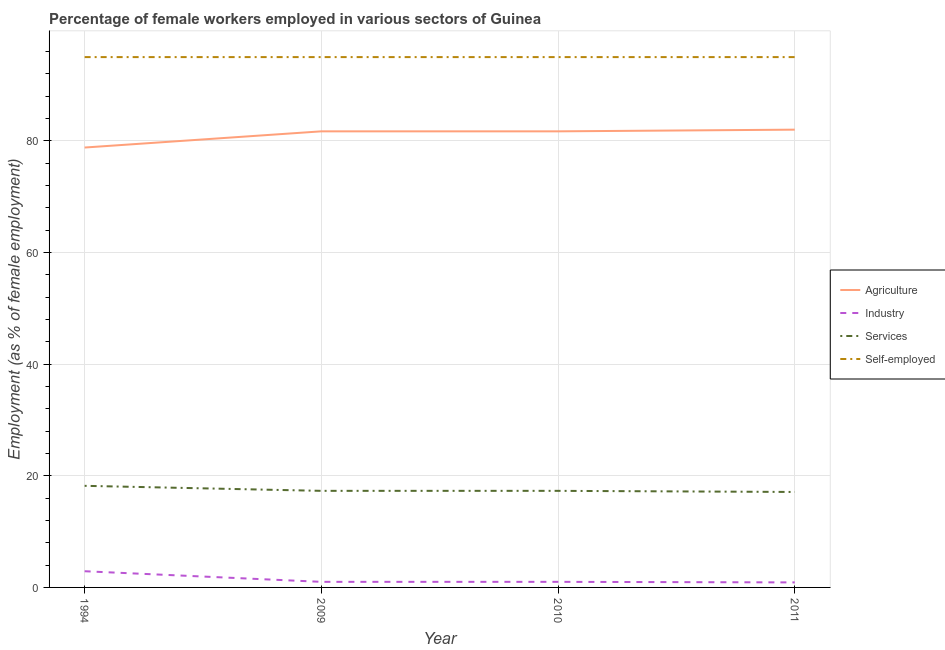How many different coloured lines are there?
Give a very brief answer. 4. What is the percentage of female workers in industry in 1994?
Give a very brief answer. 2.9. Across all years, what is the minimum percentage of self employed female workers?
Keep it short and to the point. 95. In which year was the percentage of self employed female workers maximum?
Offer a terse response. 1994. What is the total percentage of self employed female workers in the graph?
Offer a very short reply. 380. What is the difference between the percentage of female workers in services in 1994 and the percentage of female workers in agriculture in 2010?
Make the answer very short. -63.5. What is the average percentage of female workers in industry per year?
Provide a short and direct response. 1.45. In the year 1994, what is the difference between the percentage of self employed female workers and percentage of female workers in agriculture?
Offer a very short reply. 16.2. In how many years, is the percentage of female workers in services greater than 24 %?
Offer a very short reply. 0. What is the ratio of the percentage of female workers in agriculture in 1994 to that in 2010?
Keep it short and to the point. 0.96. Is the percentage of female workers in services in 1994 less than that in 2010?
Give a very brief answer. No. Is the difference between the percentage of female workers in services in 2009 and 2011 greater than the difference between the percentage of female workers in agriculture in 2009 and 2011?
Provide a short and direct response. Yes. What is the difference between the highest and the second highest percentage of female workers in agriculture?
Keep it short and to the point. 0.3. What is the difference between the highest and the lowest percentage of female workers in services?
Your answer should be compact. 1.1. Is the sum of the percentage of female workers in services in 2009 and 2010 greater than the maximum percentage of female workers in industry across all years?
Your response must be concise. Yes. Is it the case that in every year, the sum of the percentage of female workers in industry and percentage of female workers in agriculture is greater than the sum of percentage of female workers in services and percentage of self employed female workers?
Give a very brief answer. No. Is it the case that in every year, the sum of the percentage of female workers in agriculture and percentage of female workers in industry is greater than the percentage of female workers in services?
Give a very brief answer. Yes. Is the percentage of female workers in agriculture strictly greater than the percentage of female workers in industry over the years?
Your answer should be very brief. Yes. Are the values on the major ticks of Y-axis written in scientific E-notation?
Keep it short and to the point. No. Does the graph contain any zero values?
Ensure brevity in your answer.  No. Does the graph contain grids?
Provide a succinct answer. Yes. Where does the legend appear in the graph?
Provide a short and direct response. Center right. How many legend labels are there?
Offer a very short reply. 4. How are the legend labels stacked?
Make the answer very short. Vertical. What is the title of the graph?
Provide a succinct answer. Percentage of female workers employed in various sectors of Guinea. What is the label or title of the Y-axis?
Offer a terse response. Employment (as % of female employment). What is the Employment (as % of female employment) in Agriculture in 1994?
Keep it short and to the point. 78.8. What is the Employment (as % of female employment) of Industry in 1994?
Offer a terse response. 2.9. What is the Employment (as % of female employment) of Services in 1994?
Offer a very short reply. 18.2. What is the Employment (as % of female employment) of Self-employed in 1994?
Your answer should be compact. 95. What is the Employment (as % of female employment) of Agriculture in 2009?
Provide a short and direct response. 81.7. What is the Employment (as % of female employment) in Services in 2009?
Your answer should be very brief. 17.3. What is the Employment (as % of female employment) in Self-employed in 2009?
Make the answer very short. 95. What is the Employment (as % of female employment) in Agriculture in 2010?
Your answer should be very brief. 81.7. What is the Employment (as % of female employment) in Industry in 2010?
Give a very brief answer. 1. What is the Employment (as % of female employment) of Services in 2010?
Provide a succinct answer. 17.3. What is the Employment (as % of female employment) of Self-employed in 2010?
Your response must be concise. 95. What is the Employment (as % of female employment) in Agriculture in 2011?
Make the answer very short. 82. What is the Employment (as % of female employment) of Industry in 2011?
Your answer should be very brief. 0.9. What is the Employment (as % of female employment) of Services in 2011?
Make the answer very short. 17.1. What is the Employment (as % of female employment) in Self-employed in 2011?
Your answer should be very brief. 95. Across all years, what is the maximum Employment (as % of female employment) in Industry?
Your answer should be very brief. 2.9. Across all years, what is the maximum Employment (as % of female employment) of Services?
Make the answer very short. 18.2. Across all years, what is the minimum Employment (as % of female employment) in Agriculture?
Ensure brevity in your answer.  78.8. Across all years, what is the minimum Employment (as % of female employment) in Industry?
Give a very brief answer. 0.9. Across all years, what is the minimum Employment (as % of female employment) of Services?
Your response must be concise. 17.1. Across all years, what is the minimum Employment (as % of female employment) of Self-employed?
Provide a short and direct response. 95. What is the total Employment (as % of female employment) of Agriculture in the graph?
Ensure brevity in your answer.  324.2. What is the total Employment (as % of female employment) in Services in the graph?
Ensure brevity in your answer.  69.9. What is the total Employment (as % of female employment) in Self-employed in the graph?
Your answer should be very brief. 380. What is the difference between the Employment (as % of female employment) in Agriculture in 1994 and that in 2009?
Offer a very short reply. -2.9. What is the difference between the Employment (as % of female employment) in Industry in 1994 and that in 2009?
Keep it short and to the point. 1.9. What is the difference between the Employment (as % of female employment) in Industry in 1994 and that in 2010?
Your response must be concise. 1.9. What is the difference between the Employment (as % of female employment) in Services in 1994 and that in 2010?
Ensure brevity in your answer.  0.9. What is the difference between the Employment (as % of female employment) of Self-employed in 1994 and that in 2010?
Your answer should be compact. 0. What is the difference between the Employment (as % of female employment) in Industry in 1994 and that in 2011?
Make the answer very short. 2. What is the difference between the Employment (as % of female employment) of Services in 1994 and that in 2011?
Offer a very short reply. 1.1. What is the difference between the Employment (as % of female employment) of Self-employed in 1994 and that in 2011?
Your response must be concise. 0. What is the difference between the Employment (as % of female employment) in Services in 2009 and that in 2010?
Keep it short and to the point. 0. What is the difference between the Employment (as % of female employment) of Agriculture in 2009 and that in 2011?
Provide a short and direct response. -0.3. What is the difference between the Employment (as % of female employment) of Industry in 2009 and that in 2011?
Offer a very short reply. 0.1. What is the difference between the Employment (as % of female employment) of Self-employed in 2009 and that in 2011?
Offer a very short reply. 0. What is the difference between the Employment (as % of female employment) in Services in 2010 and that in 2011?
Ensure brevity in your answer.  0.2. What is the difference between the Employment (as % of female employment) in Agriculture in 1994 and the Employment (as % of female employment) in Industry in 2009?
Your answer should be very brief. 77.8. What is the difference between the Employment (as % of female employment) in Agriculture in 1994 and the Employment (as % of female employment) in Services in 2009?
Offer a very short reply. 61.5. What is the difference between the Employment (as % of female employment) in Agriculture in 1994 and the Employment (as % of female employment) in Self-employed in 2009?
Your answer should be compact. -16.2. What is the difference between the Employment (as % of female employment) of Industry in 1994 and the Employment (as % of female employment) of Services in 2009?
Your answer should be compact. -14.4. What is the difference between the Employment (as % of female employment) in Industry in 1994 and the Employment (as % of female employment) in Self-employed in 2009?
Give a very brief answer. -92.1. What is the difference between the Employment (as % of female employment) of Services in 1994 and the Employment (as % of female employment) of Self-employed in 2009?
Offer a very short reply. -76.8. What is the difference between the Employment (as % of female employment) in Agriculture in 1994 and the Employment (as % of female employment) in Industry in 2010?
Your response must be concise. 77.8. What is the difference between the Employment (as % of female employment) in Agriculture in 1994 and the Employment (as % of female employment) in Services in 2010?
Ensure brevity in your answer.  61.5. What is the difference between the Employment (as % of female employment) in Agriculture in 1994 and the Employment (as % of female employment) in Self-employed in 2010?
Keep it short and to the point. -16.2. What is the difference between the Employment (as % of female employment) in Industry in 1994 and the Employment (as % of female employment) in Services in 2010?
Your answer should be very brief. -14.4. What is the difference between the Employment (as % of female employment) in Industry in 1994 and the Employment (as % of female employment) in Self-employed in 2010?
Offer a terse response. -92.1. What is the difference between the Employment (as % of female employment) of Services in 1994 and the Employment (as % of female employment) of Self-employed in 2010?
Provide a short and direct response. -76.8. What is the difference between the Employment (as % of female employment) of Agriculture in 1994 and the Employment (as % of female employment) of Industry in 2011?
Provide a short and direct response. 77.9. What is the difference between the Employment (as % of female employment) of Agriculture in 1994 and the Employment (as % of female employment) of Services in 2011?
Your answer should be very brief. 61.7. What is the difference between the Employment (as % of female employment) of Agriculture in 1994 and the Employment (as % of female employment) of Self-employed in 2011?
Your response must be concise. -16.2. What is the difference between the Employment (as % of female employment) in Industry in 1994 and the Employment (as % of female employment) in Services in 2011?
Your response must be concise. -14.2. What is the difference between the Employment (as % of female employment) in Industry in 1994 and the Employment (as % of female employment) in Self-employed in 2011?
Provide a succinct answer. -92.1. What is the difference between the Employment (as % of female employment) in Services in 1994 and the Employment (as % of female employment) in Self-employed in 2011?
Provide a succinct answer. -76.8. What is the difference between the Employment (as % of female employment) of Agriculture in 2009 and the Employment (as % of female employment) of Industry in 2010?
Ensure brevity in your answer.  80.7. What is the difference between the Employment (as % of female employment) in Agriculture in 2009 and the Employment (as % of female employment) in Services in 2010?
Make the answer very short. 64.4. What is the difference between the Employment (as % of female employment) of Agriculture in 2009 and the Employment (as % of female employment) of Self-employed in 2010?
Give a very brief answer. -13.3. What is the difference between the Employment (as % of female employment) in Industry in 2009 and the Employment (as % of female employment) in Services in 2010?
Your answer should be compact. -16.3. What is the difference between the Employment (as % of female employment) of Industry in 2009 and the Employment (as % of female employment) of Self-employed in 2010?
Keep it short and to the point. -94. What is the difference between the Employment (as % of female employment) of Services in 2009 and the Employment (as % of female employment) of Self-employed in 2010?
Your answer should be compact. -77.7. What is the difference between the Employment (as % of female employment) in Agriculture in 2009 and the Employment (as % of female employment) in Industry in 2011?
Provide a short and direct response. 80.8. What is the difference between the Employment (as % of female employment) of Agriculture in 2009 and the Employment (as % of female employment) of Services in 2011?
Provide a short and direct response. 64.6. What is the difference between the Employment (as % of female employment) of Agriculture in 2009 and the Employment (as % of female employment) of Self-employed in 2011?
Provide a short and direct response. -13.3. What is the difference between the Employment (as % of female employment) in Industry in 2009 and the Employment (as % of female employment) in Services in 2011?
Your response must be concise. -16.1. What is the difference between the Employment (as % of female employment) of Industry in 2009 and the Employment (as % of female employment) of Self-employed in 2011?
Keep it short and to the point. -94. What is the difference between the Employment (as % of female employment) in Services in 2009 and the Employment (as % of female employment) in Self-employed in 2011?
Your response must be concise. -77.7. What is the difference between the Employment (as % of female employment) of Agriculture in 2010 and the Employment (as % of female employment) of Industry in 2011?
Provide a succinct answer. 80.8. What is the difference between the Employment (as % of female employment) of Agriculture in 2010 and the Employment (as % of female employment) of Services in 2011?
Make the answer very short. 64.6. What is the difference between the Employment (as % of female employment) in Agriculture in 2010 and the Employment (as % of female employment) in Self-employed in 2011?
Make the answer very short. -13.3. What is the difference between the Employment (as % of female employment) in Industry in 2010 and the Employment (as % of female employment) in Services in 2011?
Provide a succinct answer. -16.1. What is the difference between the Employment (as % of female employment) in Industry in 2010 and the Employment (as % of female employment) in Self-employed in 2011?
Provide a succinct answer. -94. What is the difference between the Employment (as % of female employment) in Services in 2010 and the Employment (as % of female employment) in Self-employed in 2011?
Provide a short and direct response. -77.7. What is the average Employment (as % of female employment) of Agriculture per year?
Offer a terse response. 81.05. What is the average Employment (as % of female employment) of Industry per year?
Your answer should be compact. 1.45. What is the average Employment (as % of female employment) in Services per year?
Provide a succinct answer. 17.48. What is the average Employment (as % of female employment) in Self-employed per year?
Your answer should be compact. 95. In the year 1994, what is the difference between the Employment (as % of female employment) in Agriculture and Employment (as % of female employment) in Industry?
Provide a short and direct response. 75.9. In the year 1994, what is the difference between the Employment (as % of female employment) of Agriculture and Employment (as % of female employment) of Services?
Provide a succinct answer. 60.6. In the year 1994, what is the difference between the Employment (as % of female employment) of Agriculture and Employment (as % of female employment) of Self-employed?
Your answer should be compact. -16.2. In the year 1994, what is the difference between the Employment (as % of female employment) of Industry and Employment (as % of female employment) of Services?
Offer a terse response. -15.3. In the year 1994, what is the difference between the Employment (as % of female employment) in Industry and Employment (as % of female employment) in Self-employed?
Keep it short and to the point. -92.1. In the year 1994, what is the difference between the Employment (as % of female employment) in Services and Employment (as % of female employment) in Self-employed?
Give a very brief answer. -76.8. In the year 2009, what is the difference between the Employment (as % of female employment) of Agriculture and Employment (as % of female employment) of Industry?
Offer a very short reply. 80.7. In the year 2009, what is the difference between the Employment (as % of female employment) of Agriculture and Employment (as % of female employment) of Services?
Keep it short and to the point. 64.4. In the year 2009, what is the difference between the Employment (as % of female employment) of Agriculture and Employment (as % of female employment) of Self-employed?
Your answer should be compact. -13.3. In the year 2009, what is the difference between the Employment (as % of female employment) of Industry and Employment (as % of female employment) of Services?
Offer a terse response. -16.3. In the year 2009, what is the difference between the Employment (as % of female employment) of Industry and Employment (as % of female employment) of Self-employed?
Ensure brevity in your answer.  -94. In the year 2009, what is the difference between the Employment (as % of female employment) of Services and Employment (as % of female employment) of Self-employed?
Offer a very short reply. -77.7. In the year 2010, what is the difference between the Employment (as % of female employment) of Agriculture and Employment (as % of female employment) of Industry?
Offer a terse response. 80.7. In the year 2010, what is the difference between the Employment (as % of female employment) in Agriculture and Employment (as % of female employment) in Services?
Give a very brief answer. 64.4. In the year 2010, what is the difference between the Employment (as % of female employment) of Industry and Employment (as % of female employment) of Services?
Ensure brevity in your answer.  -16.3. In the year 2010, what is the difference between the Employment (as % of female employment) in Industry and Employment (as % of female employment) in Self-employed?
Your answer should be very brief. -94. In the year 2010, what is the difference between the Employment (as % of female employment) in Services and Employment (as % of female employment) in Self-employed?
Ensure brevity in your answer.  -77.7. In the year 2011, what is the difference between the Employment (as % of female employment) in Agriculture and Employment (as % of female employment) in Industry?
Offer a terse response. 81.1. In the year 2011, what is the difference between the Employment (as % of female employment) of Agriculture and Employment (as % of female employment) of Services?
Your answer should be very brief. 64.9. In the year 2011, what is the difference between the Employment (as % of female employment) of Agriculture and Employment (as % of female employment) of Self-employed?
Your answer should be very brief. -13. In the year 2011, what is the difference between the Employment (as % of female employment) of Industry and Employment (as % of female employment) of Services?
Give a very brief answer. -16.2. In the year 2011, what is the difference between the Employment (as % of female employment) of Industry and Employment (as % of female employment) of Self-employed?
Provide a short and direct response. -94.1. In the year 2011, what is the difference between the Employment (as % of female employment) of Services and Employment (as % of female employment) of Self-employed?
Your answer should be compact. -77.9. What is the ratio of the Employment (as % of female employment) in Agriculture in 1994 to that in 2009?
Give a very brief answer. 0.96. What is the ratio of the Employment (as % of female employment) in Services in 1994 to that in 2009?
Offer a terse response. 1.05. What is the ratio of the Employment (as % of female employment) in Self-employed in 1994 to that in 2009?
Offer a terse response. 1. What is the ratio of the Employment (as % of female employment) in Agriculture in 1994 to that in 2010?
Provide a succinct answer. 0.96. What is the ratio of the Employment (as % of female employment) of Services in 1994 to that in 2010?
Your answer should be compact. 1.05. What is the ratio of the Employment (as % of female employment) in Industry in 1994 to that in 2011?
Make the answer very short. 3.22. What is the ratio of the Employment (as % of female employment) of Services in 1994 to that in 2011?
Your response must be concise. 1.06. What is the ratio of the Employment (as % of female employment) of Services in 2009 to that in 2010?
Ensure brevity in your answer.  1. What is the ratio of the Employment (as % of female employment) in Agriculture in 2009 to that in 2011?
Offer a terse response. 1. What is the ratio of the Employment (as % of female employment) of Industry in 2009 to that in 2011?
Your answer should be compact. 1.11. What is the ratio of the Employment (as % of female employment) in Services in 2009 to that in 2011?
Provide a succinct answer. 1.01. What is the ratio of the Employment (as % of female employment) of Agriculture in 2010 to that in 2011?
Offer a very short reply. 1. What is the ratio of the Employment (as % of female employment) of Services in 2010 to that in 2011?
Keep it short and to the point. 1.01. What is the ratio of the Employment (as % of female employment) in Self-employed in 2010 to that in 2011?
Give a very brief answer. 1. What is the difference between the highest and the second highest Employment (as % of female employment) of Agriculture?
Provide a short and direct response. 0.3. What is the difference between the highest and the second highest Employment (as % of female employment) in Self-employed?
Provide a short and direct response. 0. What is the difference between the highest and the lowest Employment (as % of female employment) of Industry?
Give a very brief answer. 2. What is the difference between the highest and the lowest Employment (as % of female employment) in Self-employed?
Offer a terse response. 0. 